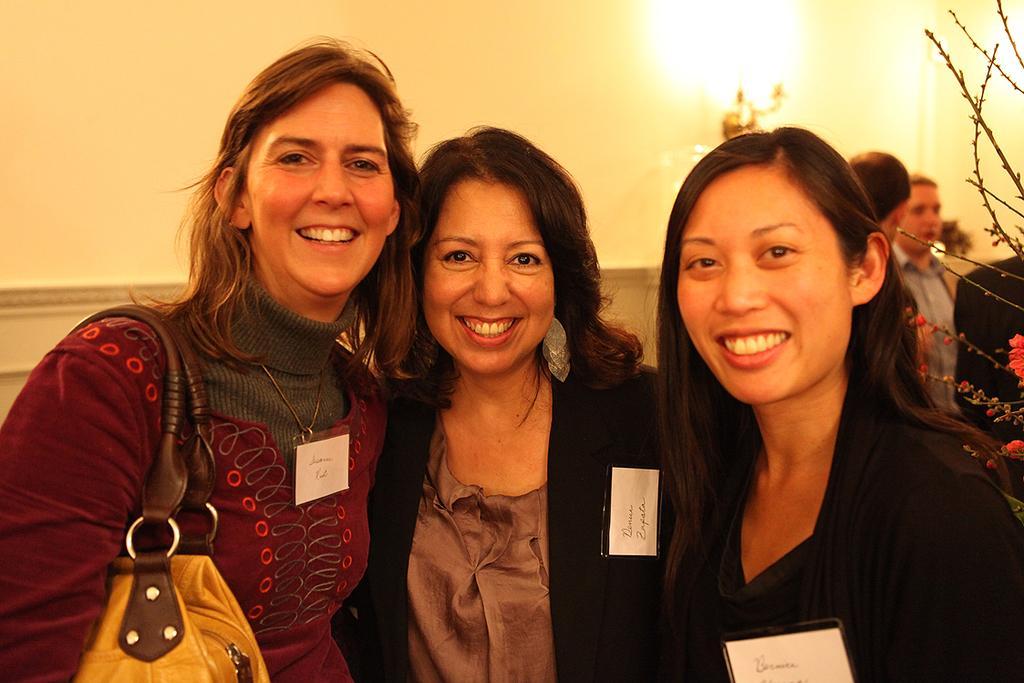Can you describe this image briefly? In this image I can see there are three women who are smiling and the woman on the left side is wearing a bag. Behind these people we have white color wall with lamp and two other people. 